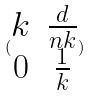Convert formula to latex. <formula><loc_0><loc_0><loc_500><loc_500>( \begin{matrix} k & \frac { d } { n k } \\ 0 & \frac { 1 } { k } \end{matrix} )</formula> 